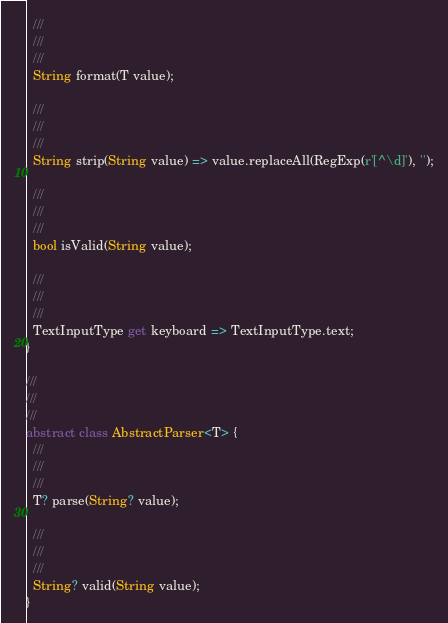Convert code to text. <code><loc_0><loc_0><loc_500><loc_500><_Dart_>  ///
  ///
  ///
  String format(T value);

  ///
  ///
  ///
  String strip(String value) => value.replaceAll(RegExp(r'[^\d]'), '');

  ///
  ///
  ///
  bool isValid(String value);

  ///
  ///
  ///
  TextInputType get keyboard => TextInputType.text;
}

///
///
///
abstract class AbstractParser<T> {
  ///
  ///
  ///
  T? parse(String? value);

  ///
  ///
  ///
  String? valid(String value);
}
</code> 